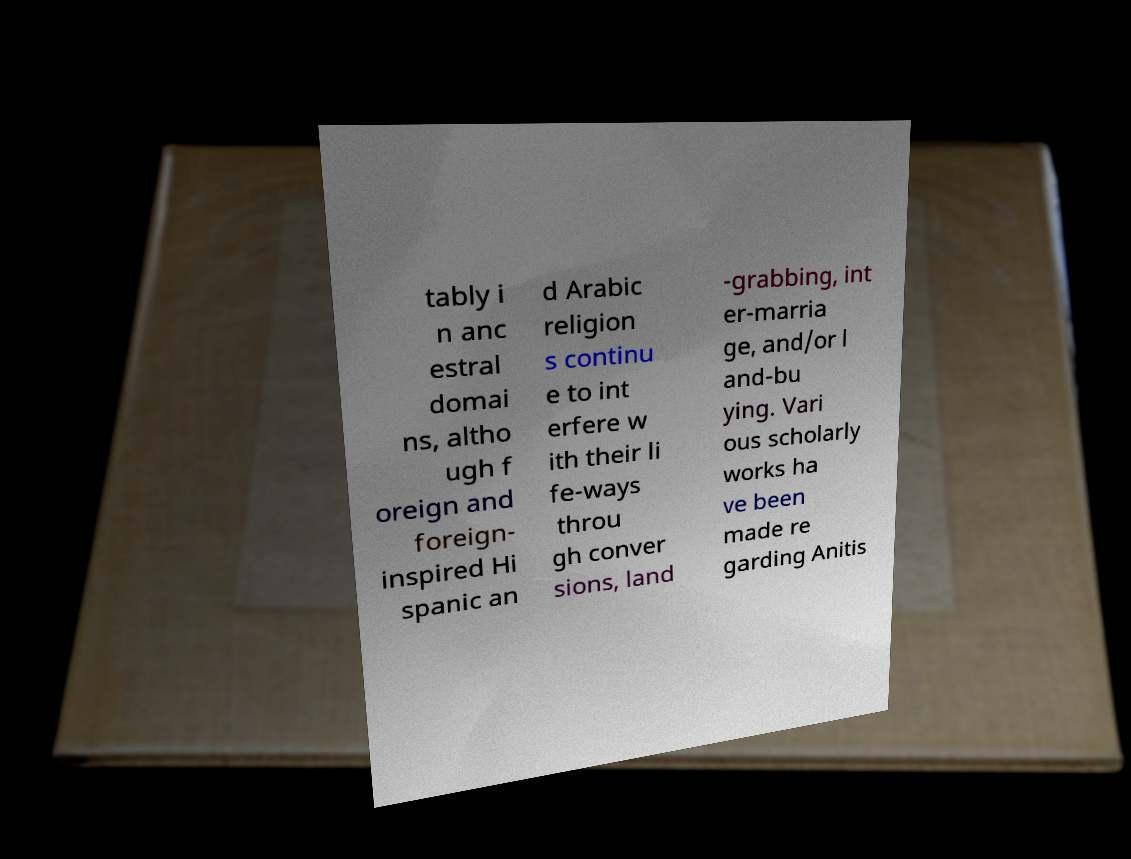What messages or text are displayed in this image? I need them in a readable, typed format. tably i n anc estral domai ns, altho ugh f oreign and foreign- inspired Hi spanic an d Arabic religion s continu e to int erfere w ith their li fe-ways throu gh conver sions, land -grabbing, int er-marria ge, and/or l and-bu ying. Vari ous scholarly works ha ve been made re garding Anitis 